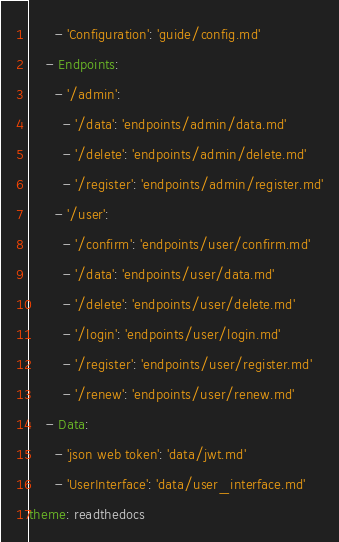<code> <loc_0><loc_0><loc_500><loc_500><_YAML_>      - 'Configuration': 'guide/config.md'
    - Endpoints:
      - '/admin':
        - '/data': 'endpoints/admin/data.md'
        - '/delete': 'endpoints/admin/delete.md'
        - '/register': 'endpoints/admin/register.md'
      - '/user':
        - '/confirm': 'endpoints/user/confirm.md'
        - '/data': 'endpoints/user/data.md'
        - '/delete': 'endpoints/user/delete.md'
        - '/login': 'endpoints/user/login.md'
        - '/register': 'endpoints/user/register.md'
        - '/renew': 'endpoints/user/renew.md'
    - Data:
      - 'json web token': 'data/jwt.md'
      - 'UserInterface': 'data/user_interface.md'
theme: readthedocs</code> 